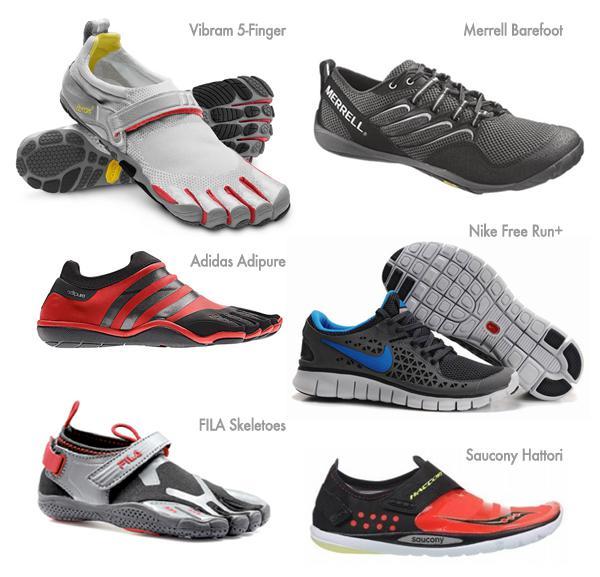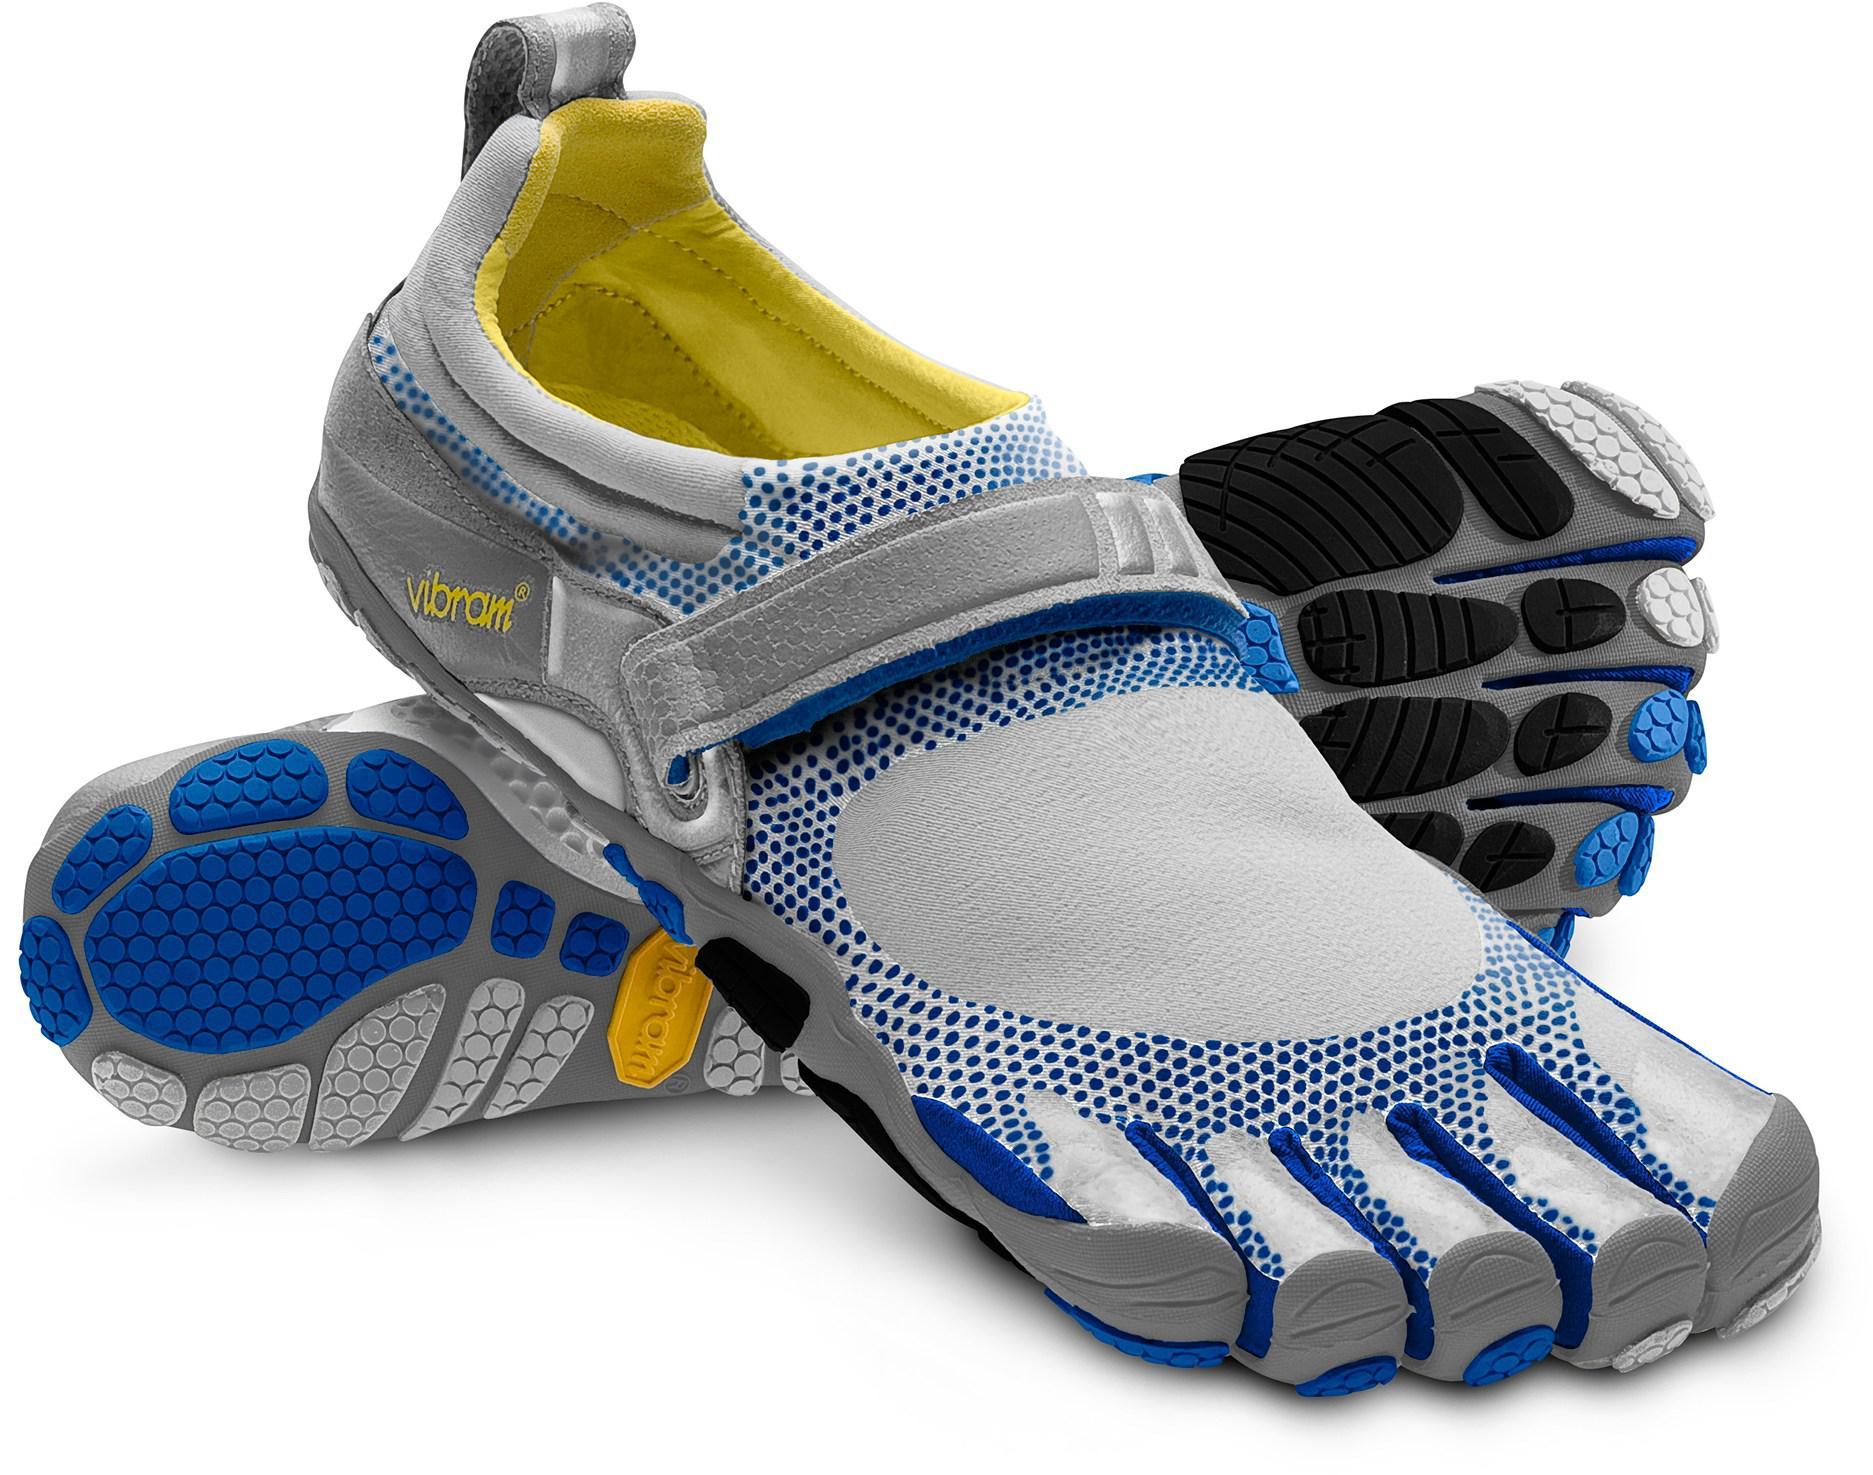The first image is the image on the left, the second image is the image on the right. Examine the images to the left and right. Is the description "The left hand image shows both the top and the bottom of the pair of shoes that are not on a person, while the right hand image shows shoes being worn by a human." accurate? Answer yes or no. No. The first image is the image on the left, the second image is the image on the right. Given the left and right images, does the statement "One image shows a pair of feet in sneakers, and the other shows a pair of unworn shoes, one turned so its sole faces the camera." hold true? Answer yes or no. No. 